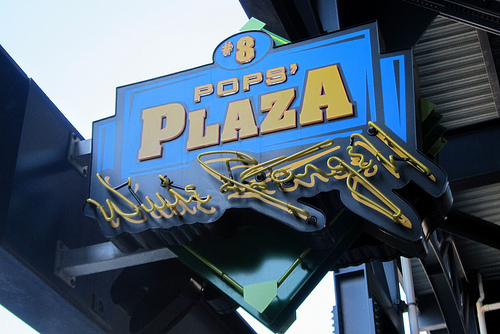<image>
Can you confirm if the letter p is on the sign? Yes. Looking at the image, I can see the letter p is positioned on top of the sign, with the sign providing support. 